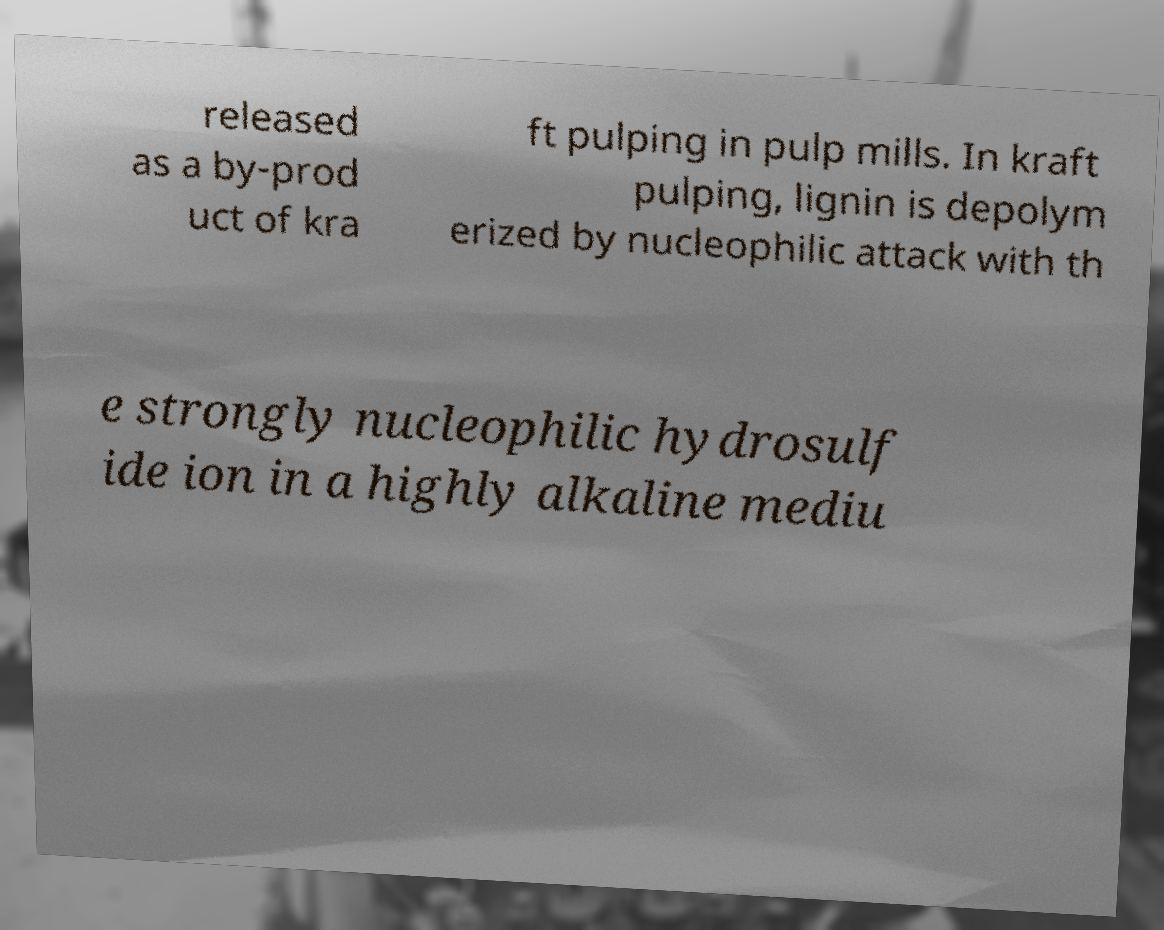Can you read and provide the text displayed in the image?This photo seems to have some interesting text. Can you extract and type it out for me? released as a by-prod uct of kra ft pulping in pulp mills. In kraft pulping, lignin is depolym erized by nucleophilic attack with th e strongly nucleophilic hydrosulf ide ion in a highly alkaline mediu 